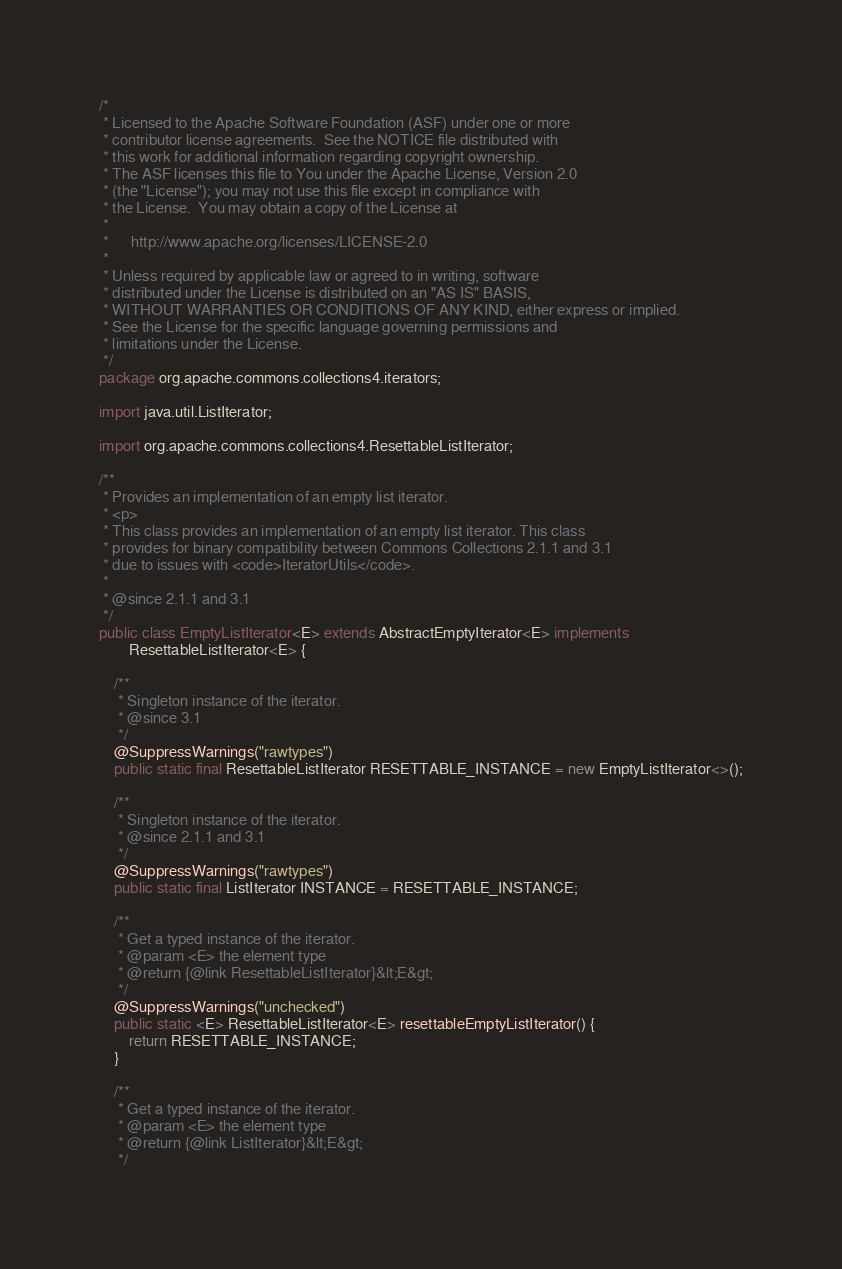<code> <loc_0><loc_0><loc_500><loc_500><_Java_>/*
 * Licensed to the Apache Software Foundation (ASF) under one or more
 * contributor license agreements.  See the NOTICE file distributed with
 * this work for additional information regarding copyright ownership.
 * The ASF licenses this file to You under the Apache License, Version 2.0
 * (the "License"); you may not use this file except in compliance with
 * the License.  You may obtain a copy of the License at
 *
 *      http://www.apache.org/licenses/LICENSE-2.0
 *
 * Unless required by applicable law or agreed to in writing, software
 * distributed under the License is distributed on an "AS IS" BASIS,
 * WITHOUT WARRANTIES OR CONDITIONS OF ANY KIND, either express or implied.
 * See the License for the specific language governing permissions and
 * limitations under the License.
 */
package org.apache.commons.collections4.iterators;

import java.util.ListIterator;

import org.apache.commons.collections4.ResettableListIterator;

/**
 * Provides an implementation of an empty list iterator.
 * <p>
 * This class provides an implementation of an empty list iterator. This class
 * provides for binary compatibility between Commons Collections 2.1.1 and 3.1
 * due to issues with <code>IteratorUtils</code>.
 *
 * @since 2.1.1 and 3.1
 */
public class EmptyListIterator<E> extends AbstractEmptyIterator<E> implements
        ResettableListIterator<E> {

    /**
     * Singleton instance of the iterator.
     * @since 3.1
     */
    @SuppressWarnings("rawtypes")
    public static final ResettableListIterator RESETTABLE_INSTANCE = new EmptyListIterator<>();

    /**
     * Singleton instance of the iterator.
     * @since 2.1.1 and 3.1
     */
    @SuppressWarnings("rawtypes")
    public static final ListIterator INSTANCE = RESETTABLE_INSTANCE;

    /**
     * Get a typed instance of the iterator.
     * @param <E> the element type
     * @return {@link ResettableListIterator}&lt;E&gt;
     */
    @SuppressWarnings("unchecked")
	public static <E> ResettableListIterator<E> resettableEmptyListIterator() {
        return RESETTABLE_INSTANCE;
    }

    /**
     * Get a typed instance of the iterator.
     * @param <E> the element type
     * @return {@link ListIterator}&lt;E&gt;
     */</code> 